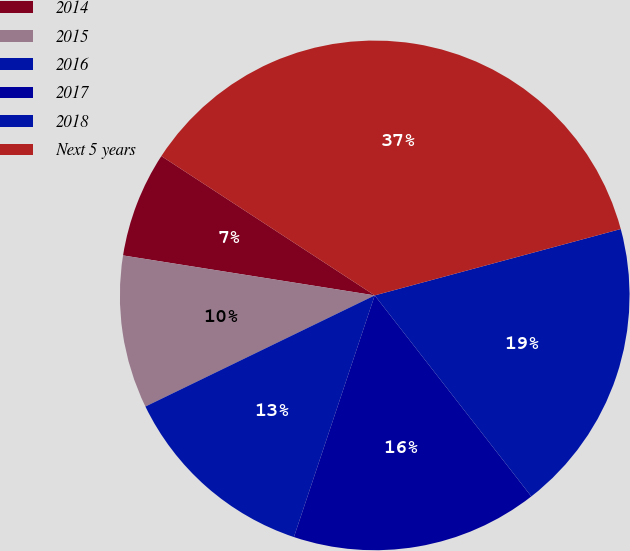Convert chart to OTSL. <chart><loc_0><loc_0><loc_500><loc_500><pie_chart><fcel>2014<fcel>2015<fcel>2016<fcel>2017<fcel>2018<fcel>Next 5 years<nl><fcel>6.7%<fcel>9.69%<fcel>12.68%<fcel>15.67%<fcel>18.66%<fcel>36.6%<nl></chart> 